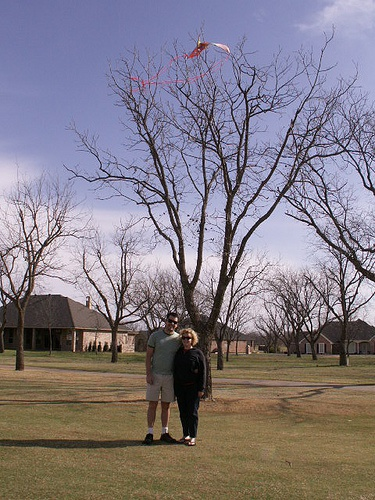Describe the objects in this image and their specific colors. I can see people in gray, black, and maroon tones, people in gray, black, and maroon tones, and kite in gray, maroon, and brown tones in this image. 